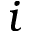Convert formula to latex. <formula><loc_0><loc_0><loc_500><loc_500>i</formula> 